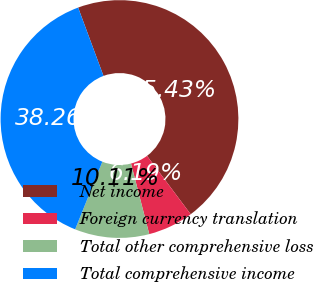Convert chart. <chart><loc_0><loc_0><loc_500><loc_500><pie_chart><fcel>Net income<fcel>Foreign currency translation<fcel>Total other comprehensive loss<fcel>Total comprehensive income<nl><fcel>45.43%<fcel>6.19%<fcel>10.11%<fcel>38.26%<nl></chart> 